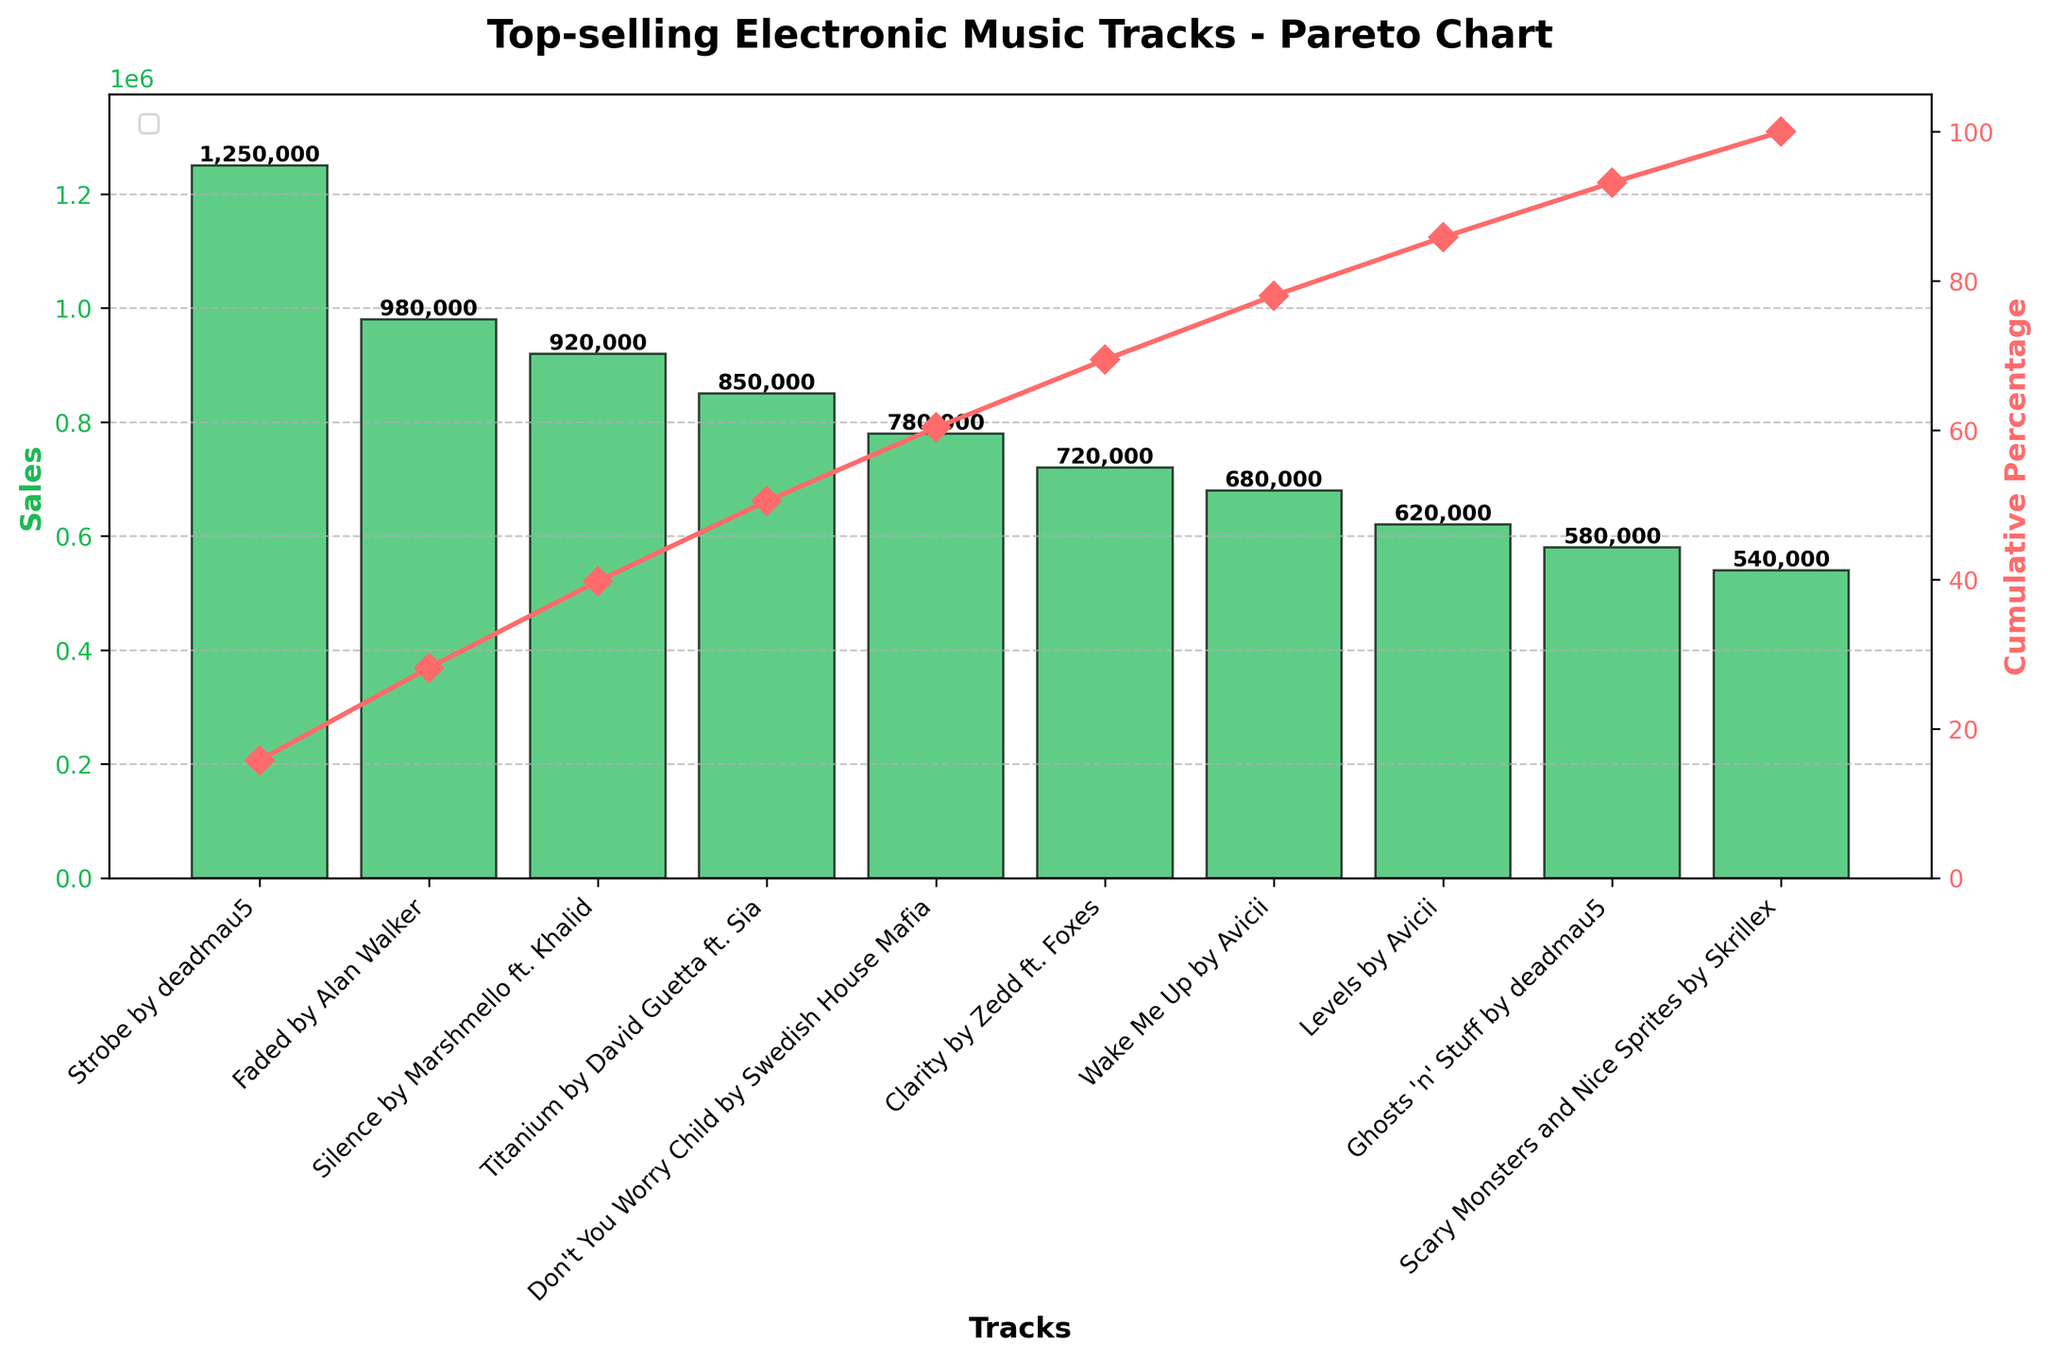What's the title of the figure? The title is typically placed at the top of the figure, providing a summary of what the chart represents. In this case, it reads "Top-selling Electronic Music Tracks - Pareto Chart".
Answer: Top-selling Electronic Music Tracks - Pareto Chart What are the platforms represented in the chart? Platforms are detected by looking at the track names and their description on the x-axis. The chart includes Beatport, Spotify, Apple Music, Amazon Music, YouTube Music, SoundCloud, Tidal, Bandcamp, Traxsource, and Juno Download.
Answer: Beatport, Spotify, Apple Music, Amazon Music, YouTube Music, SoundCloud, Tidal, Bandcamp, Traxsource, Juno Download Which track has the highest sales? The chart's y-axis indicates sales, and the highest bar corresponds to the track with the highest sales. "Strobe" by deadmau5 is at the top of the chart.
Answer: "Strobe" by deadmau5 What is the cumulative percentage for the top 3 tracks? Cumulative percentages are shown on the secondary y-axis. Adding the percentages for "Strobe" by deadmau5 (~23.6%), "Faded" by Alan Walker (~42.4%), and "Silence" by Marshmello ft. Khalid (~60.6%) will provide the cumulative.
Answer: ~60.6% What is the cumulated percentage after the fifth track? Referring to the secondary y-axis and counting the first five tracks ("Strobe," "Faded," "Silence," "Titanium," and "Don't You Worry Child"), we see that the cumulative percentage is just under 80%.
Answer: ~76.8% Compare the sales between "Strobe" by deadmau5 and "Clarity" by Zedd ft. Foxes. "Strobe" has sales of 1,250,000, while "Clarity" has 720,000. Subtracting the lower number from the higher gives the difference.
Answer: 530,000 What is the approximate percentage contribution of "Wake Me Up" by Avicii to the total sales? The sales for "Wake Me Up" are 680,000. The total sales are the sum of all the track sales, approximately 7,570,000. Calculating (680,000 / 7,570,000) * 100 gives the percentage.
Answer: ~9% How many tracks account for over 50% of the total sales? To find this, add the sales sequentially from the highest until the cumulative percentage exceeds 50%. After adding up "Strobe," "Faded," and "Silence," the percentage exceeds 50%.
Answer: 3 Which tracks have sales between 600,000 and 700,000? Referring to the y-axis for sales and checking the bars that fall within this range, "Wake Me Up" by Avicii and "Levels" by Avicii fit the criteria.
Answer: "Wake Me Up" by Avicii and "Levels" by Avicii How is the second y-axis used in this Pareto chart? The second y-axis represents the cumulative percentage of total sales, plotted as a line chart overlaid on the bar chart. Each point on the line indicates the cumulative percentage up to that track.
Answer: Cumulative percentage 